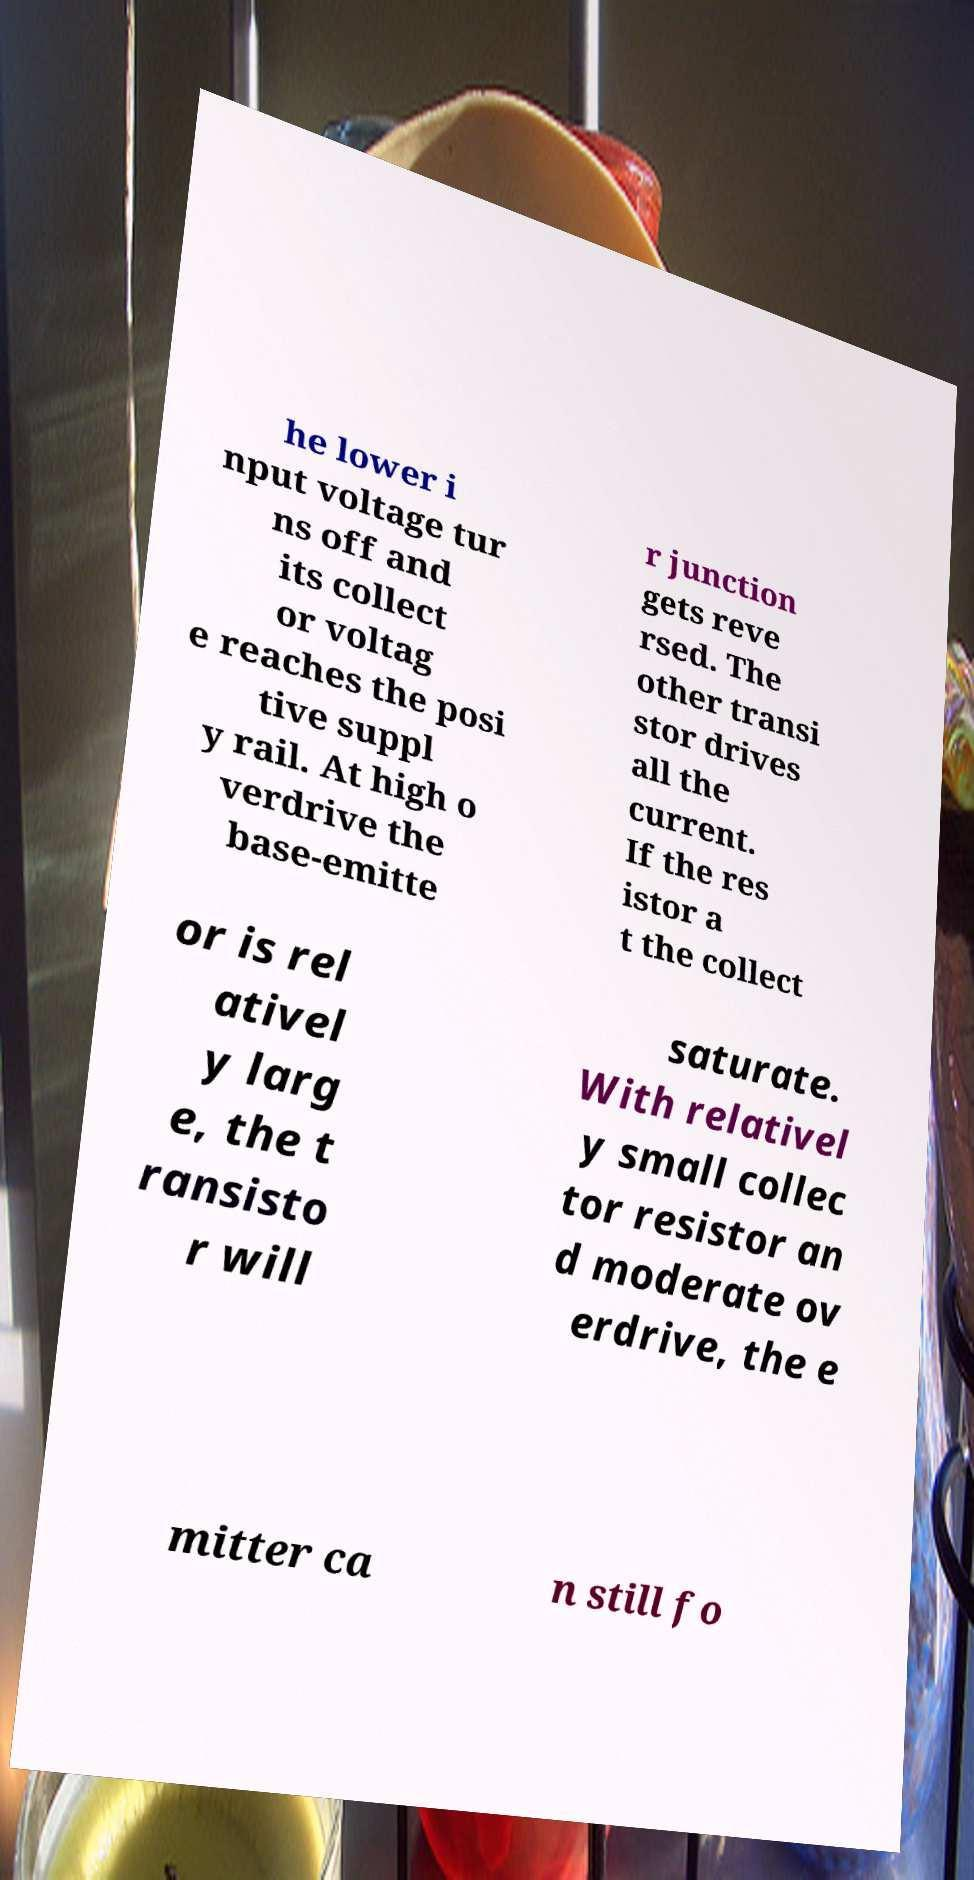Please read and relay the text visible in this image. What does it say? he lower i nput voltage tur ns off and its collect or voltag e reaches the posi tive suppl y rail. At high o verdrive the base-emitte r junction gets reve rsed. The other transi stor drives all the current. If the res istor a t the collect or is rel ativel y larg e, the t ransisto r will saturate. With relativel y small collec tor resistor an d moderate ov erdrive, the e mitter ca n still fo 